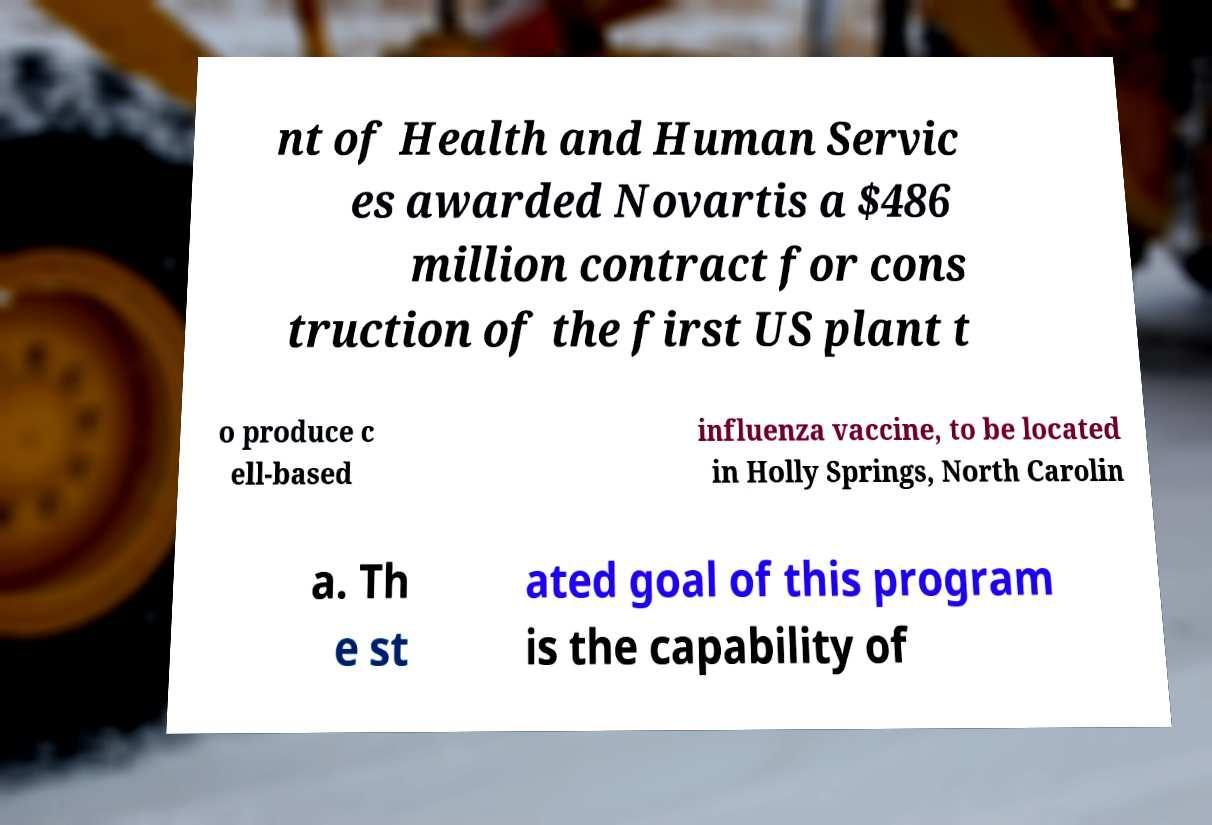I need the written content from this picture converted into text. Can you do that? nt of Health and Human Servic es awarded Novartis a $486 million contract for cons truction of the first US plant t o produce c ell-based influenza vaccine, to be located in Holly Springs, North Carolin a. Th e st ated goal of this program is the capability of 